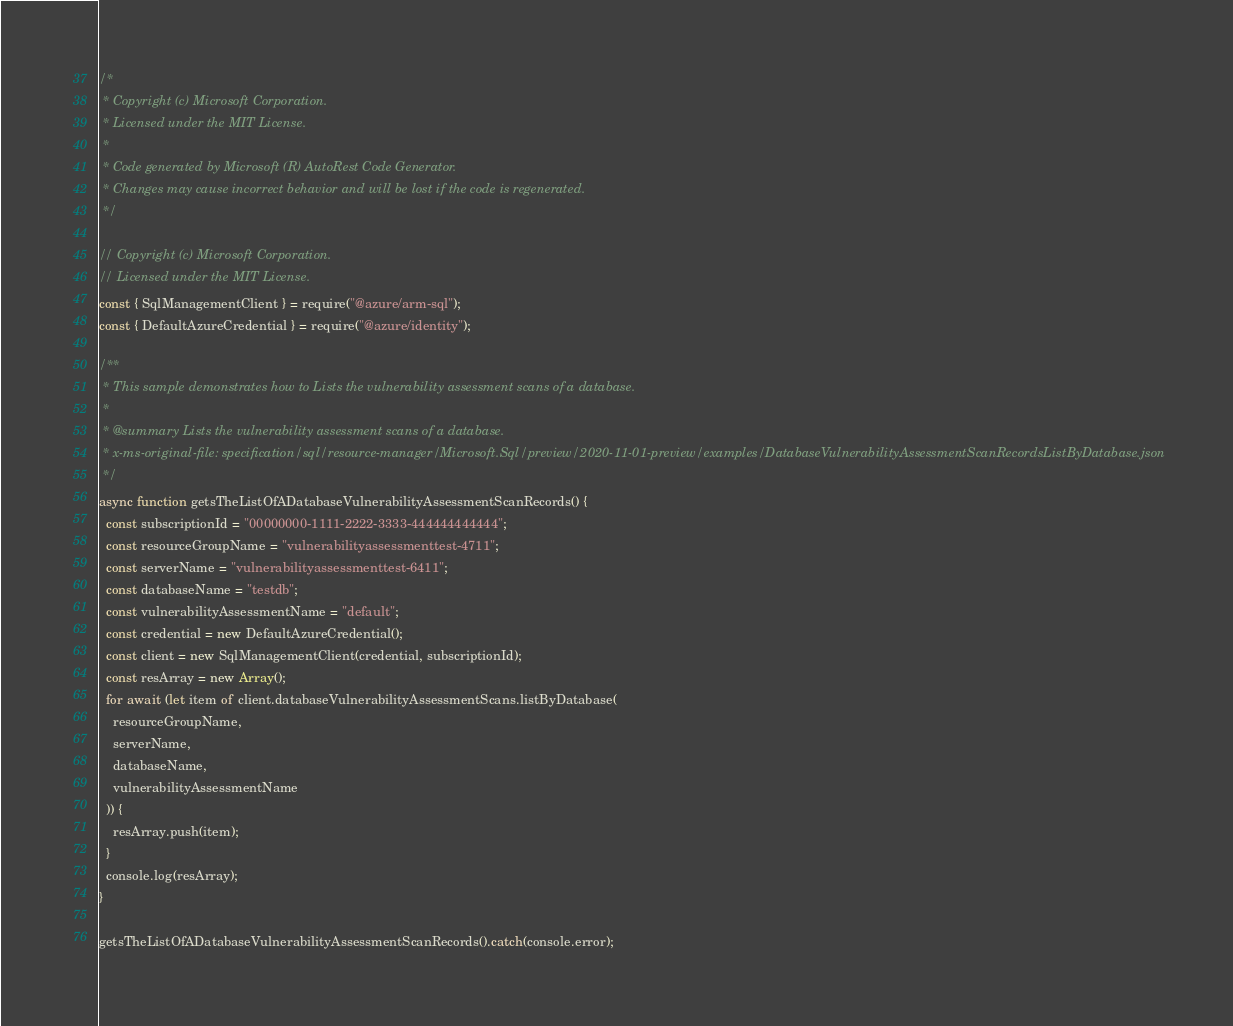<code> <loc_0><loc_0><loc_500><loc_500><_JavaScript_>/*
 * Copyright (c) Microsoft Corporation.
 * Licensed under the MIT License.
 *
 * Code generated by Microsoft (R) AutoRest Code Generator.
 * Changes may cause incorrect behavior and will be lost if the code is regenerated.
 */

// Copyright (c) Microsoft Corporation.
// Licensed under the MIT License.
const { SqlManagementClient } = require("@azure/arm-sql");
const { DefaultAzureCredential } = require("@azure/identity");

/**
 * This sample demonstrates how to Lists the vulnerability assessment scans of a database.
 *
 * @summary Lists the vulnerability assessment scans of a database.
 * x-ms-original-file: specification/sql/resource-manager/Microsoft.Sql/preview/2020-11-01-preview/examples/DatabaseVulnerabilityAssessmentScanRecordsListByDatabase.json
 */
async function getsTheListOfADatabaseVulnerabilityAssessmentScanRecords() {
  const subscriptionId = "00000000-1111-2222-3333-444444444444";
  const resourceGroupName = "vulnerabilityassessmenttest-4711";
  const serverName = "vulnerabilityassessmenttest-6411";
  const databaseName = "testdb";
  const vulnerabilityAssessmentName = "default";
  const credential = new DefaultAzureCredential();
  const client = new SqlManagementClient(credential, subscriptionId);
  const resArray = new Array();
  for await (let item of client.databaseVulnerabilityAssessmentScans.listByDatabase(
    resourceGroupName,
    serverName,
    databaseName,
    vulnerabilityAssessmentName
  )) {
    resArray.push(item);
  }
  console.log(resArray);
}

getsTheListOfADatabaseVulnerabilityAssessmentScanRecords().catch(console.error);
</code> 